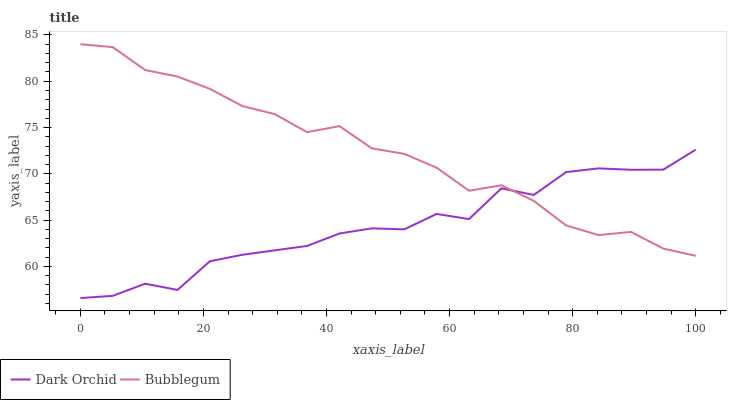Does Dark Orchid have the maximum area under the curve?
Answer yes or no. No. Is Dark Orchid the smoothest?
Answer yes or no. No. Does Dark Orchid have the highest value?
Answer yes or no. No. 